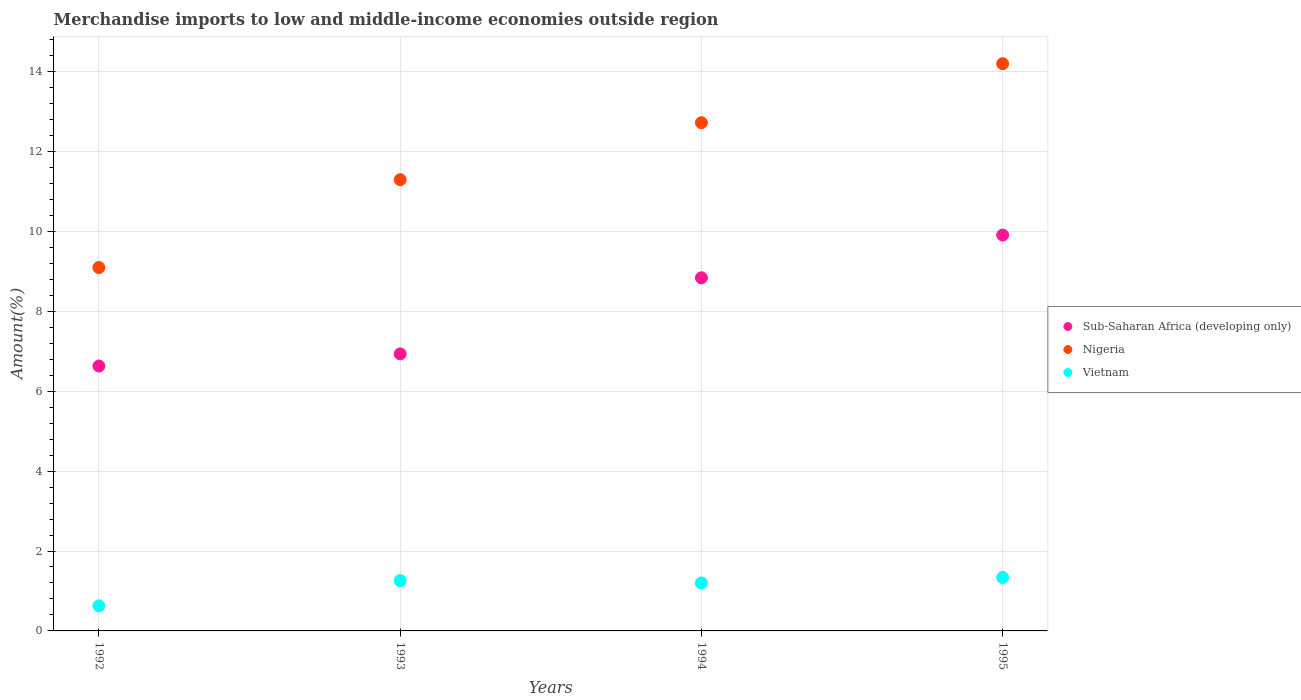How many different coloured dotlines are there?
Your answer should be very brief. 3. What is the percentage of amount earned from merchandise imports in Vietnam in 1994?
Your answer should be compact. 1.2. Across all years, what is the maximum percentage of amount earned from merchandise imports in Nigeria?
Provide a short and direct response. 14.2. Across all years, what is the minimum percentage of amount earned from merchandise imports in Vietnam?
Give a very brief answer. 0.63. What is the total percentage of amount earned from merchandise imports in Sub-Saharan Africa (developing only) in the graph?
Keep it short and to the point. 32.31. What is the difference between the percentage of amount earned from merchandise imports in Nigeria in 1993 and that in 1994?
Provide a succinct answer. -1.42. What is the difference between the percentage of amount earned from merchandise imports in Nigeria in 1993 and the percentage of amount earned from merchandise imports in Vietnam in 1992?
Provide a short and direct response. 10.67. What is the average percentage of amount earned from merchandise imports in Vietnam per year?
Give a very brief answer. 1.11. In the year 1994, what is the difference between the percentage of amount earned from merchandise imports in Nigeria and percentage of amount earned from merchandise imports in Sub-Saharan Africa (developing only)?
Make the answer very short. 3.88. In how many years, is the percentage of amount earned from merchandise imports in Sub-Saharan Africa (developing only) greater than 4.8 %?
Make the answer very short. 4. What is the ratio of the percentage of amount earned from merchandise imports in Nigeria in 1992 to that in 1993?
Make the answer very short. 0.81. Is the percentage of amount earned from merchandise imports in Sub-Saharan Africa (developing only) in 1994 less than that in 1995?
Provide a short and direct response. Yes. Is the difference between the percentage of amount earned from merchandise imports in Nigeria in 1992 and 1994 greater than the difference between the percentage of amount earned from merchandise imports in Sub-Saharan Africa (developing only) in 1992 and 1994?
Provide a short and direct response. No. What is the difference between the highest and the second highest percentage of amount earned from merchandise imports in Sub-Saharan Africa (developing only)?
Keep it short and to the point. 1.07. What is the difference between the highest and the lowest percentage of amount earned from merchandise imports in Sub-Saharan Africa (developing only)?
Your response must be concise. 3.28. Is the sum of the percentage of amount earned from merchandise imports in Sub-Saharan Africa (developing only) in 1992 and 1995 greater than the maximum percentage of amount earned from merchandise imports in Nigeria across all years?
Keep it short and to the point. Yes. Does the percentage of amount earned from merchandise imports in Sub-Saharan Africa (developing only) monotonically increase over the years?
Give a very brief answer. Yes. Is the percentage of amount earned from merchandise imports in Vietnam strictly greater than the percentage of amount earned from merchandise imports in Nigeria over the years?
Give a very brief answer. No. Is the percentage of amount earned from merchandise imports in Vietnam strictly less than the percentage of amount earned from merchandise imports in Sub-Saharan Africa (developing only) over the years?
Make the answer very short. Yes. Does the graph contain grids?
Offer a very short reply. Yes. How are the legend labels stacked?
Make the answer very short. Vertical. What is the title of the graph?
Provide a short and direct response. Merchandise imports to low and middle-income economies outside region. What is the label or title of the Y-axis?
Provide a short and direct response. Amount(%). What is the Amount(%) of Sub-Saharan Africa (developing only) in 1992?
Ensure brevity in your answer.  6.63. What is the Amount(%) in Nigeria in 1992?
Offer a very short reply. 9.09. What is the Amount(%) in Vietnam in 1992?
Provide a succinct answer. 0.63. What is the Amount(%) of Sub-Saharan Africa (developing only) in 1993?
Your answer should be very brief. 6.93. What is the Amount(%) of Nigeria in 1993?
Your answer should be compact. 11.29. What is the Amount(%) in Vietnam in 1993?
Offer a very short reply. 1.26. What is the Amount(%) in Sub-Saharan Africa (developing only) in 1994?
Provide a short and direct response. 8.84. What is the Amount(%) of Nigeria in 1994?
Provide a short and direct response. 12.72. What is the Amount(%) of Vietnam in 1994?
Offer a terse response. 1.2. What is the Amount(%) of Sub-Saharan Africa (developing only) in 1995?
Provide a succinct answer. 9.91. What is the Amount(%) in Nigeria in 1995?
Make the answer very short. 14.2. What is the Amount(%) in Vietnam in 1995?
Your answer should be very brief. 1.34. Across all years, what is the maximum Amount(%) of Sub-Saharan Africa (developing only)?
Make the answer very short. 9.91. Across all years, what is the maximum Amount(%) of Nigeria?
Offer a very short reply. 14.2. Across all years, what is the maximum Amount(%) of Vietnam?
Provide a succinct answer. 1.34. Across all years, what is the minimum Amount(%) of Sub-Saharan Africa (developing only)?
Your answer should be compact. 6.63. Across all years, what is the minimum Amount(%) in Nigeria?
Keep it short and to the point. 9.09. Across all years, what is the minimum Amount(%) in Vietnam?
Ensure brevity in your answer.  0.63. What is the total Amount(%) in Sub-Saharan Africa (developing only) in the graph?
Keep it short and to the point. 32.31. What is the total Amount(%) in Nigeria in the graph?
Your answer should be very brief. 47.3. What is the total Amount(%) in Vietnam in the graph?
Your answer should be compact. 4.42. What is the difference between the Amount(%) in Sub-Saharan Africa (developing only) in 1992 and that in 1993?
Provide a succinct answer. -0.3. What is the difference between the Amount(%) of Nigeria in 1992 and that in 1993?
Give a very brief answer. -2.2. What is the difference between the Amount(%) of Vietnam in 1992 and that in 1993?
Give a very brief answer. -0.63. What is the difference between the Amount(%) of Sub-Saharan Africa (developing only) in 1992 and that in 1994?
Give a very brief answer. -2.21. What is the difference between the Amount(%) in Nigeria in 1992 and that in 1994?
Provide a succinct answer. -3.62. What is the difference between the Amount(%) of Vietnam in 1992 and that in 1994?
Ensure brevity in your answer.  -0.57. What is the difference between the Amount(%) in Sub-Saharan Africa (developing only) in 1992 and that in 1995?
Give a very brief answer. -3.28. What is the difference between the Amount(%) of Nigeria in 1992 and that in 1995?
Offer a terse response. -5.1. What is the difference between the Amount(%) in Vietnam in 1992 and that in 1995?
Offer a terse response. -0.71. What is the difference between the Amount(%) in Sub-Saharan Africa (developing only) in 1993 and that in 1994?
Your answer should be very brief. -1.9. What is the difference between the Amount(%) of Nigeria in 1993 and that in 1994?
Make the answer very short. -1.42. What is the difference between the Amount(%) of Vietnam in 1993 and that in 1994?
Make the answer very short. 0.06. What is the difference between the Amount(%) of Sub-Saharan Africa (developing only) in 1993 and that in 1995?
Your answer should be compact. -2.97. What is the difference between the Amount(%) of Nigeria in 1993 and that in 1995?
Give a very brief answer. -2.9. What is the difference between the Amount(%) of Vietnam in 1993 and that in 1995?
Provide a short and direct response. -0.08. What is the difference between the Amount(%) in Sub-Saharan Africa (developing only) in 1994 and that in 1995?
Offer a very short reply. -1.07. What is the difference between the Amount(%) of Nigeria in 1994 and that in 1995?
Your answer should be very brief. -1.48. What is the difference between the Amount(%) in Vietnam in 1994 and that in 1995?
Your answer should be very brief. -0.14. What is the difference between the Amount(%) of Sub-Saharan Africa (developing only) in 1992 and the Amount(%) of Nigeria in 1993?
Provide a succinct answer. -4.66. What is the difference between the Amount(%) in Sub-Saharan Africa (developing only) in 1992 and the Amount(%) in Vietnam in 1993?
Make the answer very short. 5.37. What is the difference between the Amount(%) of Nigeria in 1992 and the Amount(%) of Vietnam in 1993?
Your answer should be very brief. 7.84. What is the difference between the Amount(%) of Sub-Saharan Africa (developing only) in 1992 and the Amount(%) of Nigeria in 1994?
Your response must be concise. -6.09. What is the difference between the Amount(%) in Sub-Saharan Africa (developing only) in 1992 and the Amount(%) in Vietnam in 1994?
Ensure brevity in your answer.  5.43. What is the difference between the Amount(%) in Nigeria in 1992 and the Amount(%) in Vietnam in 1994?
Provide a succinct answer. 7.89. What is the difference between the Amount(%) of Sub-Saharan Africa (developing only) in 1992 and the Amount(%) of Nigeria in 1995?
Your answer should be very brief. -7.57. What is the difference between the Amount(%) in Sub-Saharan Africa (developing only) in 1992 and the Amount(%) in Vietnam in 1995?
Ensure brevity in your answer.  5.29. What is the difference between the Amount(%) in Nigeria in 1992 and the Amount(%) in Vietnam in 1995?
Ensure brevity in your answer.  7.76. What is the difference between the Amount(%) of Sub-Saharan Africa (developing only) in 1993 and the Amount(%) of Nigeria in 1994?
Offer a very short reply. -5.78. What is the difference between the Amount(%) of Sub-Saharan Africa (developing only) in 1993 and the Amount(%) of Vietnam in 1994?
Your answer should be compact. 5.73. What is the difference between the Amount(%) of Nigeria in 1993 and the Amount(%) of Vietnam in 1994?
Provide a succinct answer. 10.09. What is the difference between the Amount(%) of Sub-Saharan Africa (developing only) in 1993 and the Amount(%) of Nigeria in 1995?
Keep it short and to the point. -7.26. What is the difference between the Amount(%) in Sub-Saharan Africa (developing only) in 1993 and the Amount(%) in Vietnam in 1995?
Offer a very short reply. 5.6. What is the difference between the Amount(%) of Nigeria in 1993 and the Amount(%) of Vietnam in 1995?
Your response must be concise. 9.96. What is the difference between the Amount(%) of Sub-Saharan Africa (developing only) in 1994 and the Amount(%) of Nigeria in 1995?
Offer a very short reply. -5.36. What is the difference between the Amount(%) of Sub-Saharan Africa (developing only) in 1994 and the Amount(%) of Vietnam in 1995?
Keep it short and to the point. 7.5. What is the difference between the Amount(%) of Nigeria in 1994 and the Amount(%) of Vietnam in 1995?
Keep it short and to the point. 11.38. What is the average Amount(%) in Sub-Saharan Africa (developing only) per year?
Offer a very short reply. 8.08. What is the average Amount(%) of Nigeria per year?
Your answer should be compact. 11.83. What is the average Amount(%) in Vietnam per year?
Provide a succinct answer. 1.11. In the year 1992, what is the difference between the Amount(%) of Sub-Saharan Africa (developing only) and Amount(%) of Nigeria?
Offer a terse response. -2.46. In the year 1992, what is the difference between the Amount(%) in Sub-Saharan Africa (developing only) and Amount(%) in Vietnam?
Give a very brief answer. 6. In the year 1992, what is the difference between the Amount(%) in Nigeria and Amount(%) in Vietnam?
Ensure brevity in your answer.  8.47. In the year 1993, what is the difference between the Amount(%) in Sub-Saharan Africa (developing only) and Amount(%) in Nigeria?
Give a very brief answer. -4.36. In the year 1993, what is the difference between the Amount(%) of Sub-Saharan Africa (developing only) and Amount(%) of Vietnam?
Make the answer very short. 5.67. In the year 1993, what is the difference between the Amount(%) of Nigeria and Amount(%) of Vietnam?
Your response must be concise. 10.03. In the year 1994, what is the difference between the Amount(%) of Sub-Saharan Africa (developing only) and Amount(%) of Nigeria?
Ensure brevity in your answer.  -3.88. In the year 1994, what is the difference between the Amount(%) in Sub-Saharan Africa (developing only) and Amount(%) in Vietnam?
Keep it short and to the point. 7.64. In the year 1994, what is the difference between the Amount(%) in Nigeria and Amount(%) in Vietnam?
Provide a succinct answer. 11.52. In the year 1995, what is the difference between the Amount(%) in Sub-Saharan Africa (developing only) and Amount(%) in Nigeria?
Provide a short and direct response. -4.29. In the year 1995, what is the difference between the Amount(%) of Sub-Saharan Africa (developing only) and Amount(%) of Vietnam?
Offer a very short reply. 8.57. In the year 1995, what is the difference between the Amount(%) in Nigeria and Amount(%) in Vietnam?
Your answer should be very brief. 12.86. What is the ratio of the Amount(%) of Sub-Saharan Africa (developing only) in 1992 to that in 1993?
Offer a very short reply. 0.96. What is the ratio of the Amount(%) of Nigeria in 1992 to that in 1993?
Your answer should be compact. 0.81. What is the ratio of the Amount(%) in Vietnam in 1992 to that in 1993?
Keep it short and to the point. 0.5. What is the ratio of the Amount(%) of Sub-Saharan Africa (developing only) in 1992 to that in 1994?
Offer a very short reply. 0.75. What is the ratio of the Amount(%) in Nigeria in 1992 to that in 1994?
Provide a short and direct response. 0.71. What is the ratio of the Amount(%) in Vietnam in 1992 to that in 1994?
Keep it short and to the point. 0.52. What is the ratio of the Amount(%) in Sub-Saharan Africa (developing only) in 1992 to that in 1995?
Ensure brevity in your answer.  0.67. What is the ratio of the Amount(%) in Nigeria in 1992 to that in 1995?
Ensure brevity in your answer.  0.64. What is the ratio of the Amount(%) in Vietnam in 1992 to that in 1995?
Make the answer very short. 0.47. What is the ratio of the Amount(%) of Sub-Saharan Africa (developing only) in 1993 to that in 1994?
Give a very brief answer. 0.78. What is the ratio of the Amount(%) of Nigeria in 1993 to that in 1994?
Ensure brevity in your answer.  0.89. What is the ratio of the Amount(%) in Vietnam in 1993 to that in 1994?
Keep it short and to the point. 1.05. What is the ratio of the Amount(%) of Sub-Saharan Africa (developing only) in 1993 to that in 1995?
Provide a short and direct response. 0.7. What is the ratio of the Amount(%) in Nigeria in 1993 to that in 1995?
Your answer should be very brief. 0.8. What is the ratio of the Amount(%) of Vietnam in 1993 to that in 1995?
Provide a succinct answer. 0.94. What is the ratio of the Amount(%) of Sub-Saharan Africa (developing only) in 1994 to that in 1995?
Give a very brief answer. 0.89. What is the ratio of the Amount(%) in Nigeria in 1994 to that in 1995?
Keep it short and to the point. 0.9. What is the ratio of the Amount(%) in Vietnam in 1994 to that in 1995?
Provide a succinct answer. 0.9. What is the difference between the highest and the second highest Amount(%) of Sub-Saharan Africa (developing only)?
Your answer should be compact. 1.07. What is the difference between the highest and the second highest Amount(%) of Nigeria?
Ensure brevity in your answer.  1.48. What is the difference between the highest and the second highest Amount(%) of Vietnam?
Offer a terse response. 0.08. What is the difference between the highest and the lowest Amount(%) of Sub-Saharan Africa (developing only)?
Provide a short and direct response. 3.28. What is the difference between the highest and the lowest Amount(%) in Nigeria?
Provide a short and direct response. 5.1. What is the difference between the highest and the lowest Amount(%) of Vietnam?
Your answer should be very brief. 0.71. 